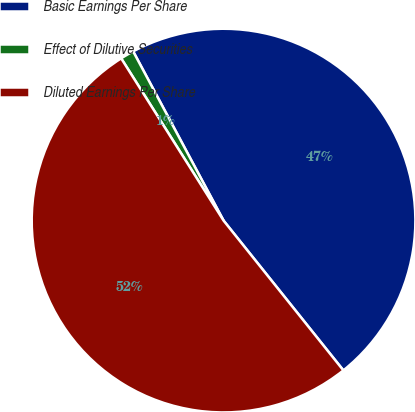Convert chart to OTSL. <chart><loc_0><loc_0><loc_500><loc_500><pie_chart><fcel>Basic Earnings Per Share<fcel>Effect of Dilutive Securities<fcel>Diluted Earnings Per Share<nl><fcel>47.07%<fcel>1.15%<fcel>51.78%<nl></chart> 